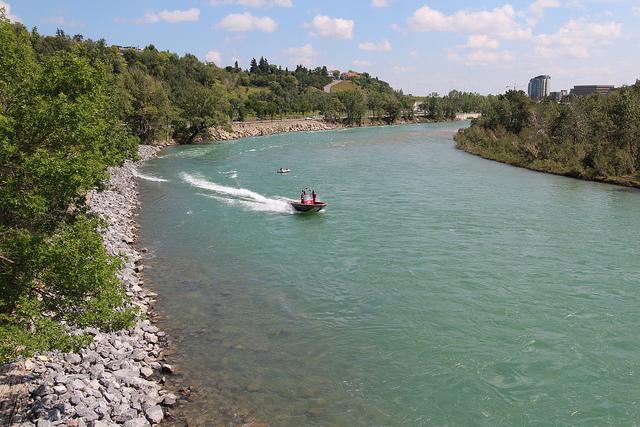Is it raining?
Concise answer only. No. Is there a boat in the water?
Give a very brief answer. Yes. Is there beach to relax on?
Be succinct. No. 